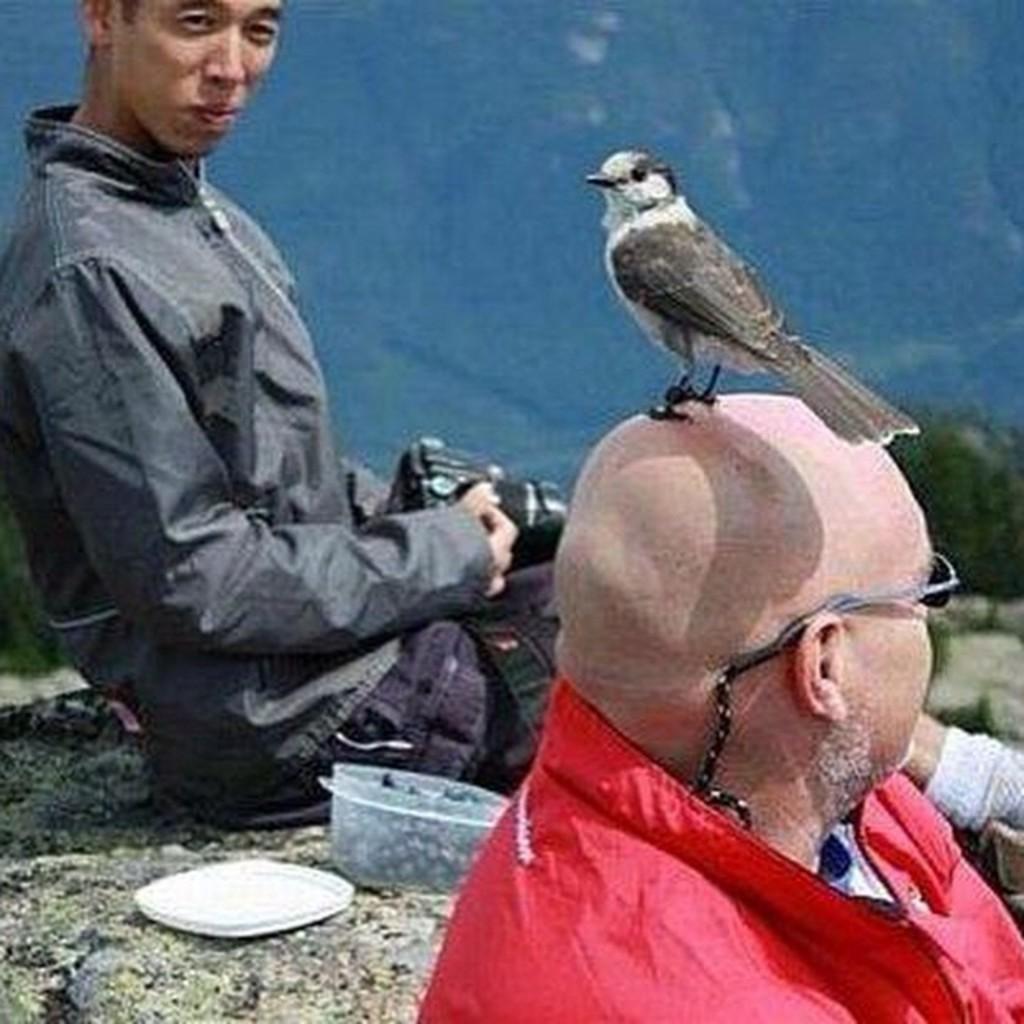Can you describe this image briefly? On the right side, there is a bird on the bald head of a person who is in a red color jacket. On the left side, there is a person in a gray color jacket, holding a camera and sitting on a rock, on which there is a box and there is its cup. In the background, there are mountains. 